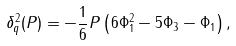<formula> <loc_0><loc_0><loc_500><loc_500>\delta _ { q } ^ { 2 } ( P ) = - \frac { 1 } { 6 } P \left ( 6 \Phi _ { 1 } ^ { 2 } - 5 \Phi _ { 3 } - \Phi _ { 1 } \right ) ,</formula> 